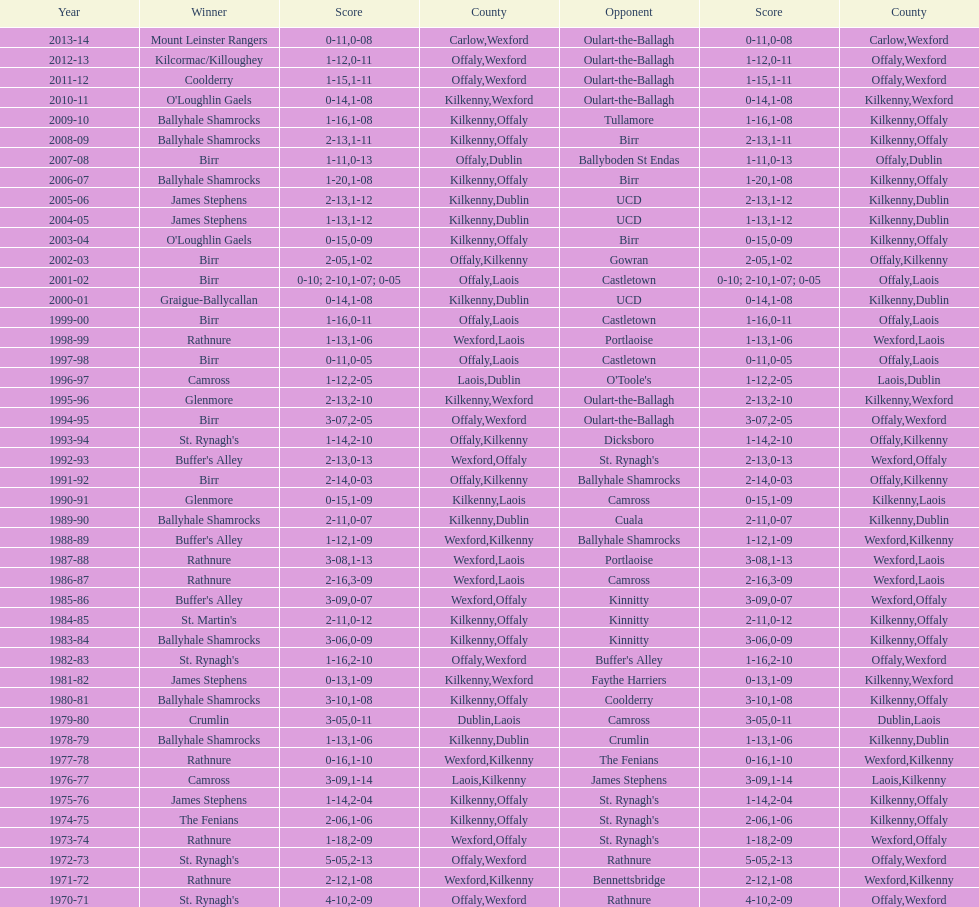For how many successive years did rathnure achieve victory? 2. 